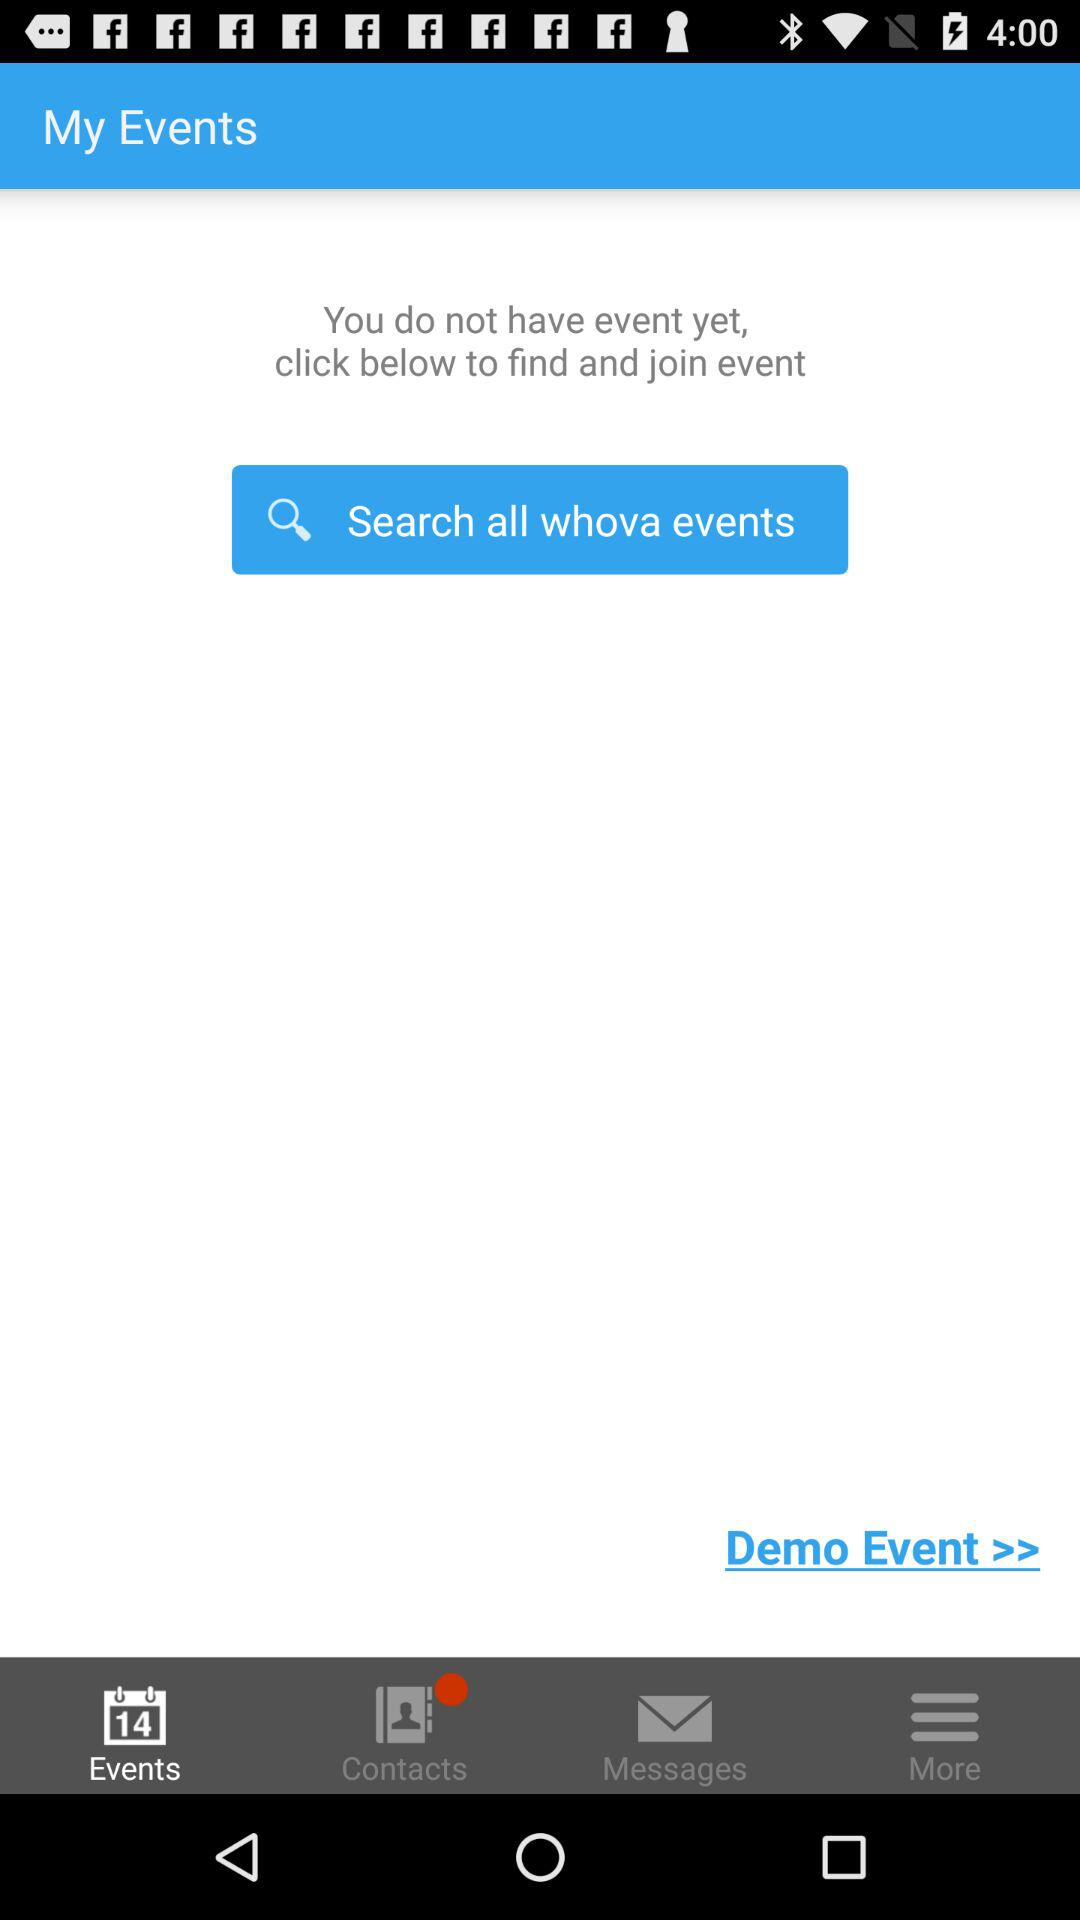How many events have been created?
Answer the question using a single word or phrase. 0 